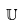Convert formula to latex. <formula><loc_0><loc_0><loc_500><loc_500>\mathbb { U }</formula> 